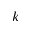Convert formula to latex. <formula><loc_0><loc_0><loc_500><loc_500>k</formula> 